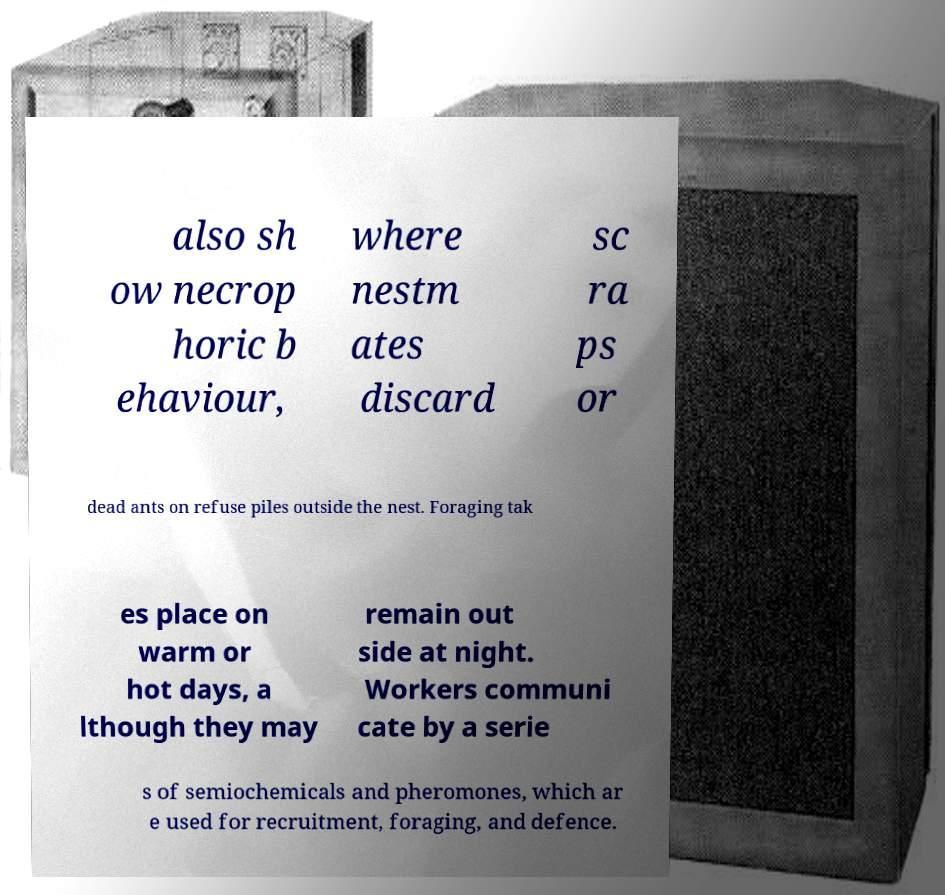There's text embedded in this image that I need extracted. Can you transcribe it verbatim? also sh ow necrop horic b ehaviour, where nestm ates discard sc ra ps or dead ants on refuse piles outside the nest. Foraging tak es place on warm or hot days, a lthough they may remain out side at night. Workers communi cate by a serie s of semiochemicals and pheromones, which ar e used for recruitment, foraging, and defence. 